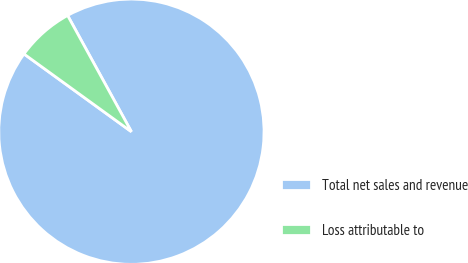<chart> <loc_0><loc_0><loc_500><loc_500><pie_chart><fcel>Total net sales and revenue<fcel>Loss attributable to<nl><fcel>92.96%<fcel>7.04%<nl></chart> 